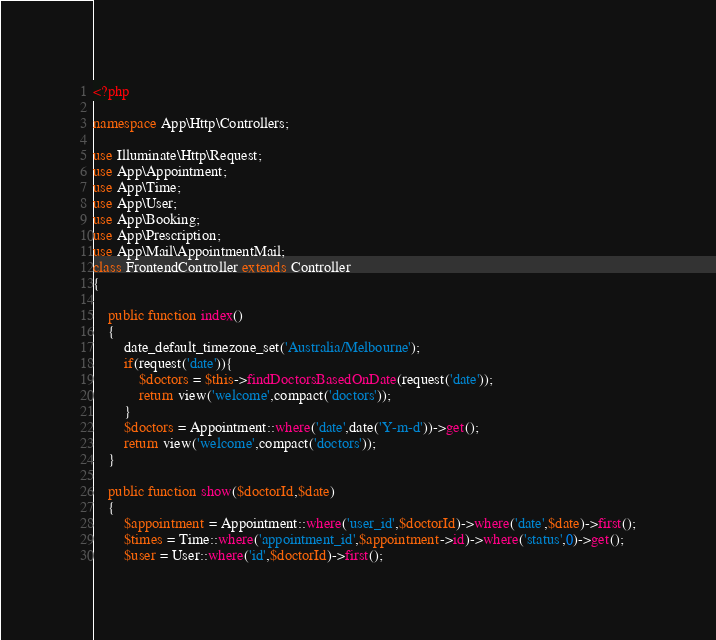Convert code to text. <code><loc_0><loc_0><loc_500><loc_500><_PHP_><?php

namespace App\Http\Controllers;

use Illuminate\Http\Request;
use App\Appointment;
use App\Time;
use App\User;
use App\Booking;
use App\Prescription;
use App\Mail\AppointmentMail;
class FrontendController extends Controller
{
    
    public function index()
    {
    	date_default_timezone_set('Australia/Melbourne');
        if(request('date')){
            $doctors = $this->findDoctorsBasedOnDate(request('date'));
            return view('welcome',compact('doctors'));
        }
        $doctors = Appointment::where('date',date('Y-m-d'))->get();
    	return view('welcome',compact('doctors'));
    }

    public function show($doctorId,$date)
    {
        $appointment = Appointment::where('user_id',$doctorId)->where('date',$date)->first();
        $times = Time::where('appointment_id',$appointment->id)->where('status',0)->get();
        $user = User::where('id',$doctorId)->first();</code> 